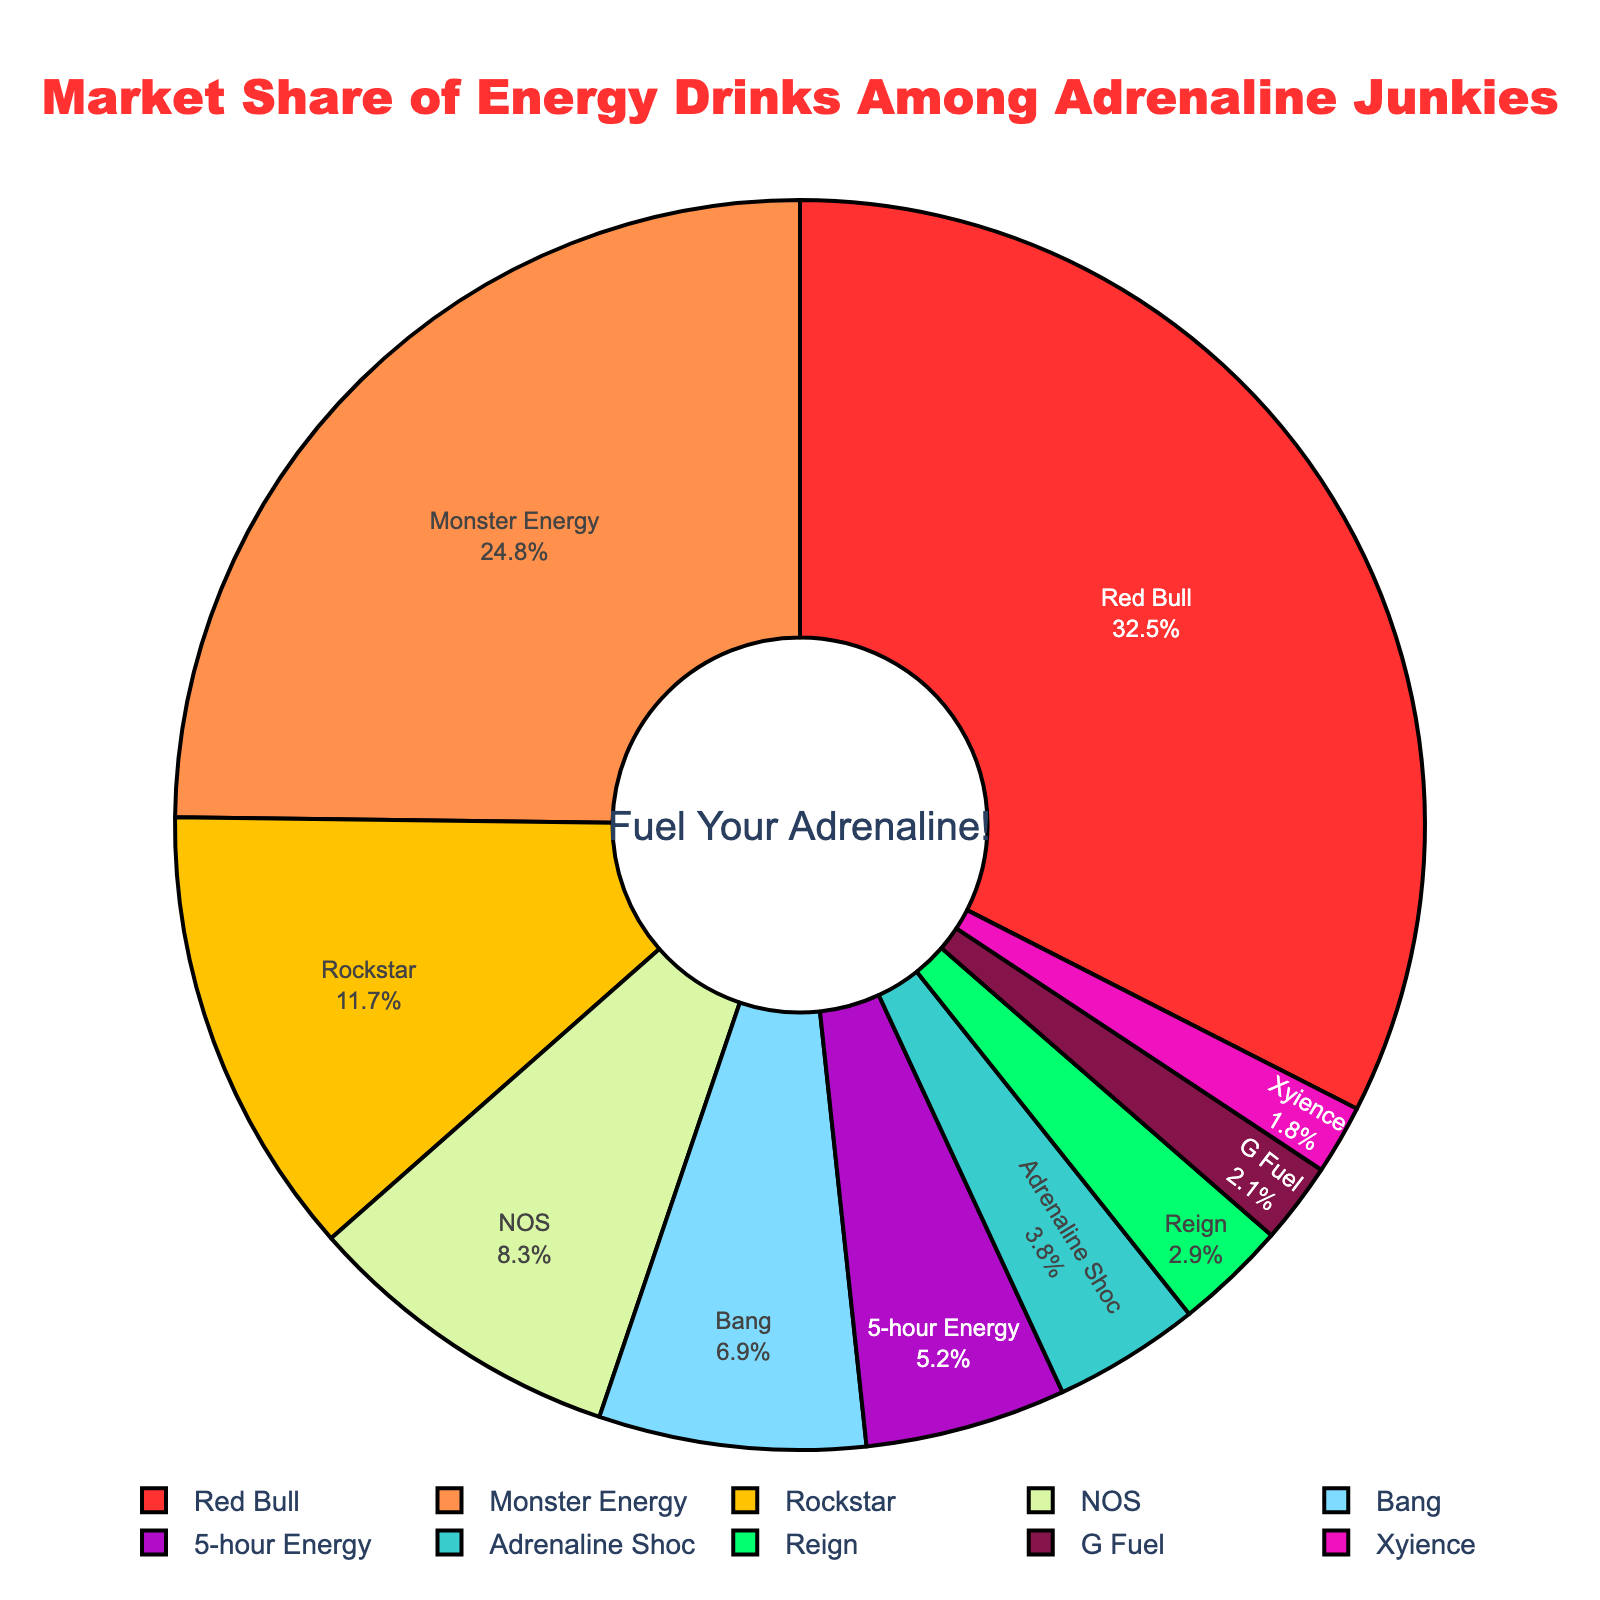Which energy drink brand has the largest market share? Look at the pie chart and identify the segment with the largest area and the corresponding label. Red Bull has the largest segment.
Answer: Red Bull What's the combined market share of Monster Energy and Rockstar? Sum the market shares of Monster Energy (24.8%) and Rockstar (11.7%). \( 24.8 + 11.7 = 36.5 \)
Answer: 36.5% Which brand has a higher market share, NOS or Bang? Compare the market shares of NOS (8.3%) and Bang (6.9%). NOS has a higher market share.
Answer: NOS How much more market share does Red Bull have compared to Monster Energy? Subtract Monster Energy's market share (24.8%) from Red Bull's market share (32.5%). \( 32.5 - 24.8 = 7.7 \)
Answer: 7.7% Identify the brand with the smallest market share and its percentage. Look at the pie chart and find the smallest segment and its corresponding label. G Fuel has the smallest segment.
Answer: G Fuel - 2.1% What is the total market share for brands with less than 10% market share each? Add up the market shares of brands with less than 10% each: Rockstar (11.7%), NOS (8.3%), Bang (6.9%), 5-hour Energy (5.2%), Adrenaline Shoc (3.8%), Reign (2.9%), G Fuel (2.1%), Xyience (1.8%). \( 5.2 + 3.8 + 2.9 + 2.1 + 1.8 = 15.8 \)
Answer: 31% How many brands have a market share greater than or equal to 10%? Count the number of brands whose segments indicate a market share of ≥ 10%. Red Bull, Monster Energy, and Rockstar have ≥ 10%.
Answer: 3 What is the average market share of the top three brands? Add the market shares of Red Bull (32.5%), Monster Energy (24.8%), and Rockstar (11.7%) and divide by 3: \( (32.5 + 24.8 + 11.7) / 3 = 23 \)
Answer: 23% Which brands have a combined market share of more than 50%? Sum the market shares of brands until the cumulative total exceeds 50%. Red Bull (32.5%) and Monster Energy (24.8%) suffices: \( 32.5 + 24.8 = 57.3 \)
Answer: Red Bull and Monster Energy Between Bang and 5-hour Energy, which brand has a lower market share? Compare the market shares of Bang (6.9%) and 5-hour Energy (5.2%). 5-hour Energy has a lower market share.
Answer: 5-hour Energy 